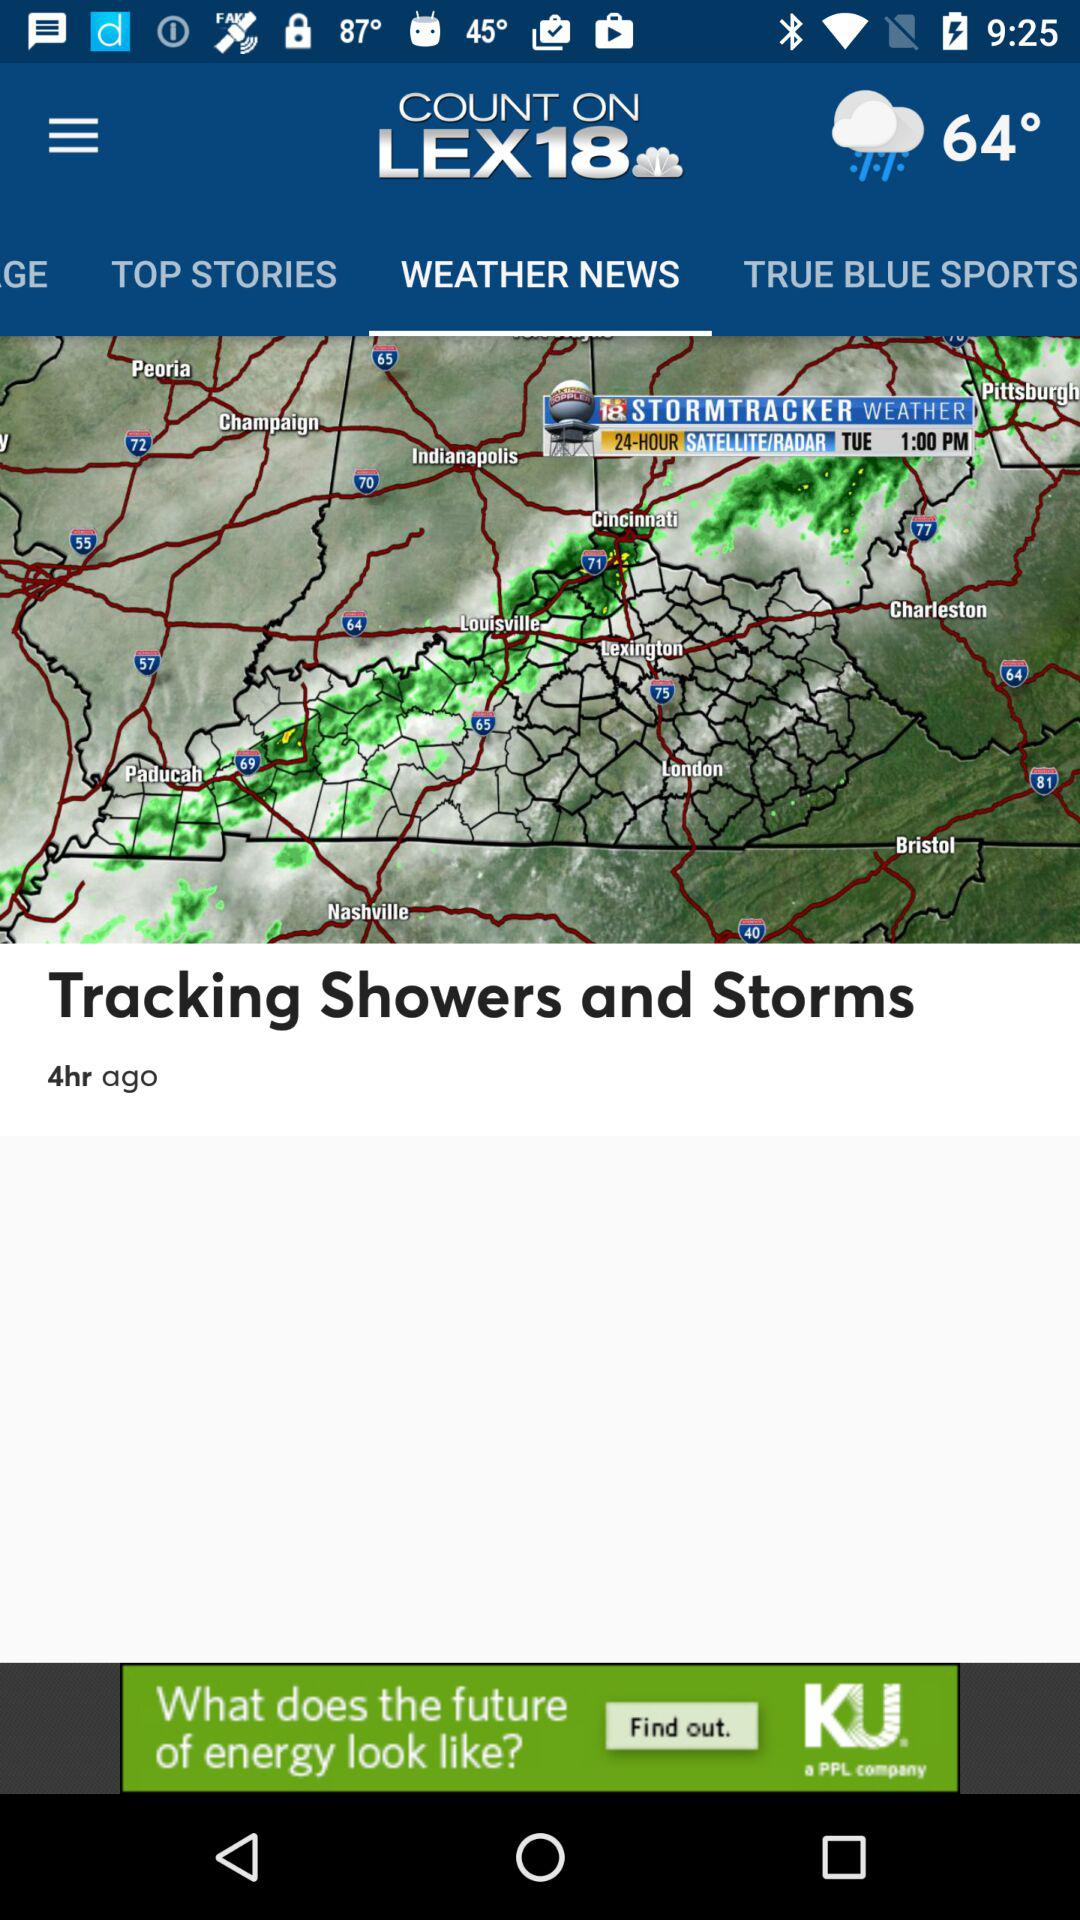What temperature is shown on the screen? The temperature shown on the screen is 64°. 